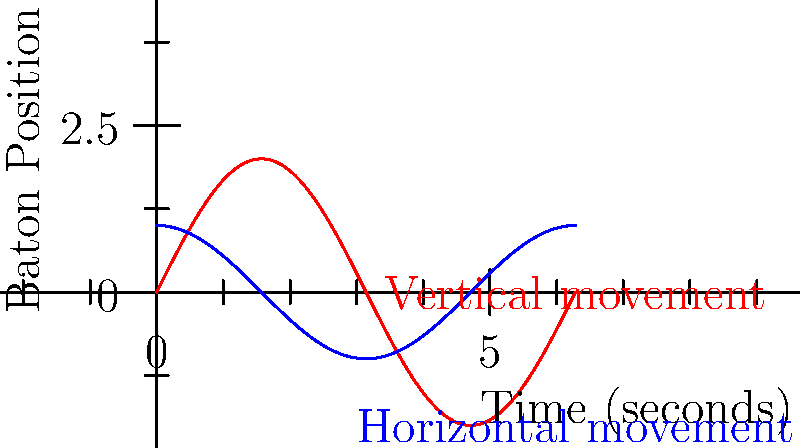The graph shows the trajectory of a conductor's baton movements during a musical piece. The red curve represents the vertical movement, and the blue curve represents the horizontal movement. If the piece lasts for 6 seconds (represented by $2\pi$ on the x-axis), at what time does the baton reach its highest point vertically? To solve this problem, we need to follow these steps:

1. Identify the function for vertical movement:
   The red curve represents vertical movement and follows the equation $y = 2\sin(x)$.

2. Find the maximum point of the sine function:
   The sine function reaches its maximum value of 1 when the angle is $\frac{\pi}{2}$ radians or 90 degrees.

3. Determine the scaling factor:
   The graph shows $2\pi$ seconds corresponding to 6 seconds of real time.
   So, the scaling factor is: $\frac{6}{2\pi} = \frac{3}{\pi}$ seconds per radian.

4. Calculate the time for the highest point:
   Time = $\frac{\pi}{2} \times \frac{3}{\pi} = \frac{3}{2} = 1.5$ seconds

Therefore, the baton reaches its highest point vertically at 1.5 seconds into the piece.
Answer: 1.5 seconds 